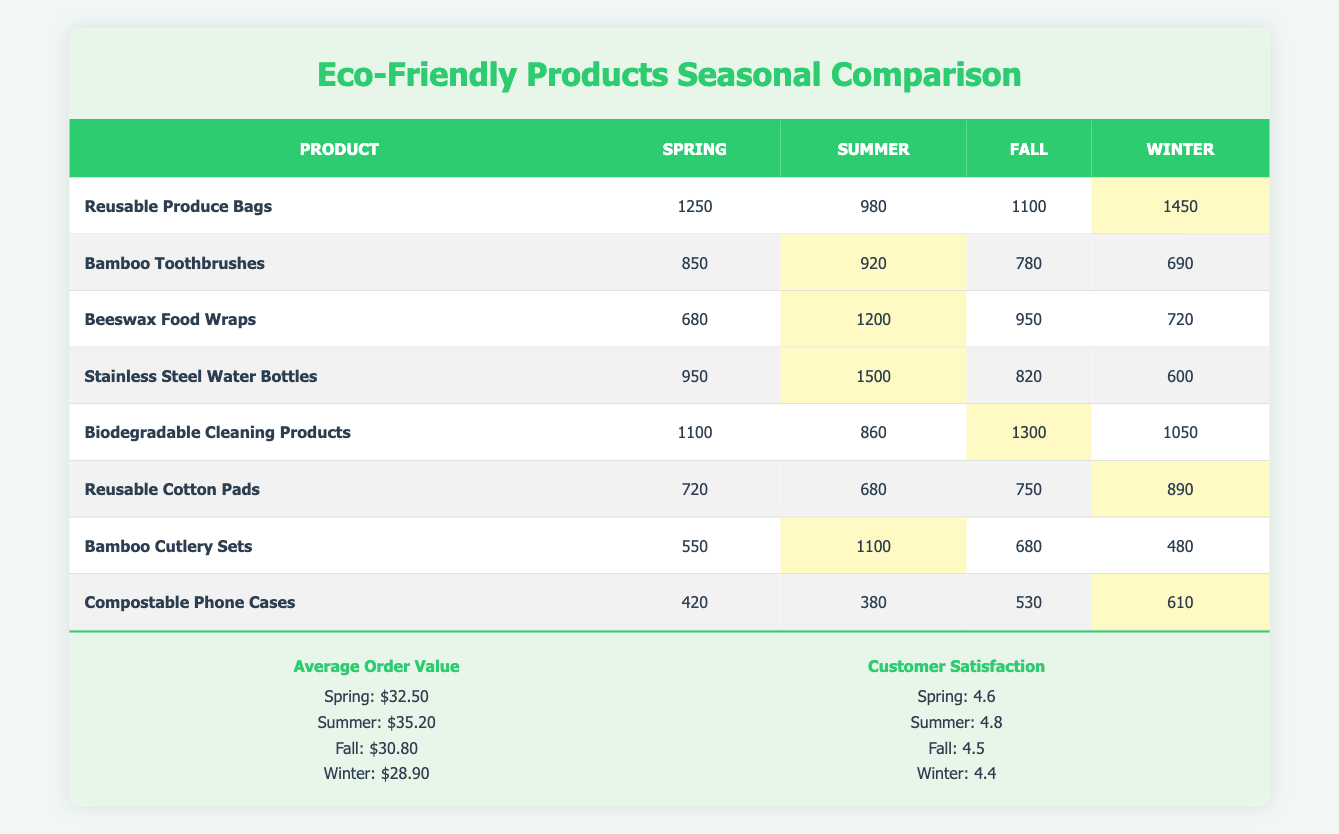What product had the highest sales in Winter? By examining the "Winter" column, the highest value is 1450 for "Reusable Produce Bags". This indicates that it was the best-selling product during the winter season.
Answer: Reusable Produce Bags Which product had the lowest sales in Spring? Looking at the "Spring" column, "Compostable Phone Cases" has the lowest sales at 420. Therefore, it is the product with the least amount of sales in the Spring season.
Answer: Compostable Phone Cases What is the average sales of Beeswax Food Wraps across all seasons? Adding the sales from all seasons for "Beeswax Food Wraps": 680 (Spring) + 1200 (Summer) + 950 (Fall) + 720 (Winter) = 2850. There are 4 seasons, so the average sales is 2850 / 4 = 712.5.
Answer: 712.5 Did "Bamboo Toothbrushes" perform better in Summer or Winter? Comparing the sales of "Bamboo Toothbrushes", Summer sales are 920 while Winter sales are 690. Since 920 is greater than 690, it performed better in Summer.
Answer: Yes Which season had the highest average order value? The average order values listed per season are: Spring $32.50, Summer $35.20, Fall $30.80, and Winter $28.90. The highest value among these is for Summer at $35.20.
Answer: Summer What is the total sales of Reusable Cotton Pads across all seasons? The sales for "Reusable Cotton Pads" are: 720 (Spring) + 680 (Summer) + 750 (Fall) + 890 (Winter) = 3040. Thus, the total sales across all seasons are 3040.
Answer: 3040 Which product had consistent sales across all seasons? By inspecting the sales data, we see that "Bamboo Cutlery Sets" have mostly lower numbers: 550 (Spring), 1100 (Summer), 680 (Fall), and 480 (Winter). There is a considerable variation, especially in Summer. Therefore, none of the products show consistent sales across all seasons.
Answer: No What were the customer satisfaction ratings in Fall and Winter, and which season had the higher rating? The ratings are 4.5 for Fall and 4.4 for Winter. Comparing these values, Fall has a slightly higher rating than Winter.
Answer: Fall 